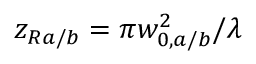Convert formula to latex. <formula><loc_0><loc_0><loc_500><loc_500>z _ { R a / b } = \pi w _ { 0 , a / b } ^ { 2 } / \lambda</formula> 